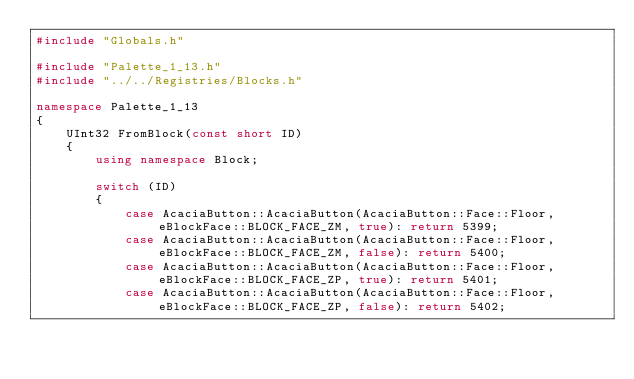<code> <loc_0><loc_0><loc_500><loc_500><_C++_>#include "Globals.h"

#include "Palette_1_13.h"
#include "../../Registries/Blocks.h"

namespace Palette_1_13
{
	UInt32 FromBlock(const short ID)
	{
		using namespace Block;

		switch (ID)
		{
			case AcaciaButton::AcaciaButton(AcaciaButton::Face::Floor, eBlockFace::BLOCK_FACE_ZM, true): return 5399;
			case AcaciaButton::AcaciaButton(AcaciaButton::Face::Floor, eBlockFace::BLOCK_FACE_ZM, false): return 5400;
			case AcaciaButton::AcaciaButton(AcaciaButton::Face::Floor, eBlockFace::BLOCK_FACE_ZP, true): return 5401;
			case AcaciaButton::AcaciaButton(AcaciaButton::Face::Floor, eBlockFace::BLOCK_FACE_ZP, false): return 5402;</code> 